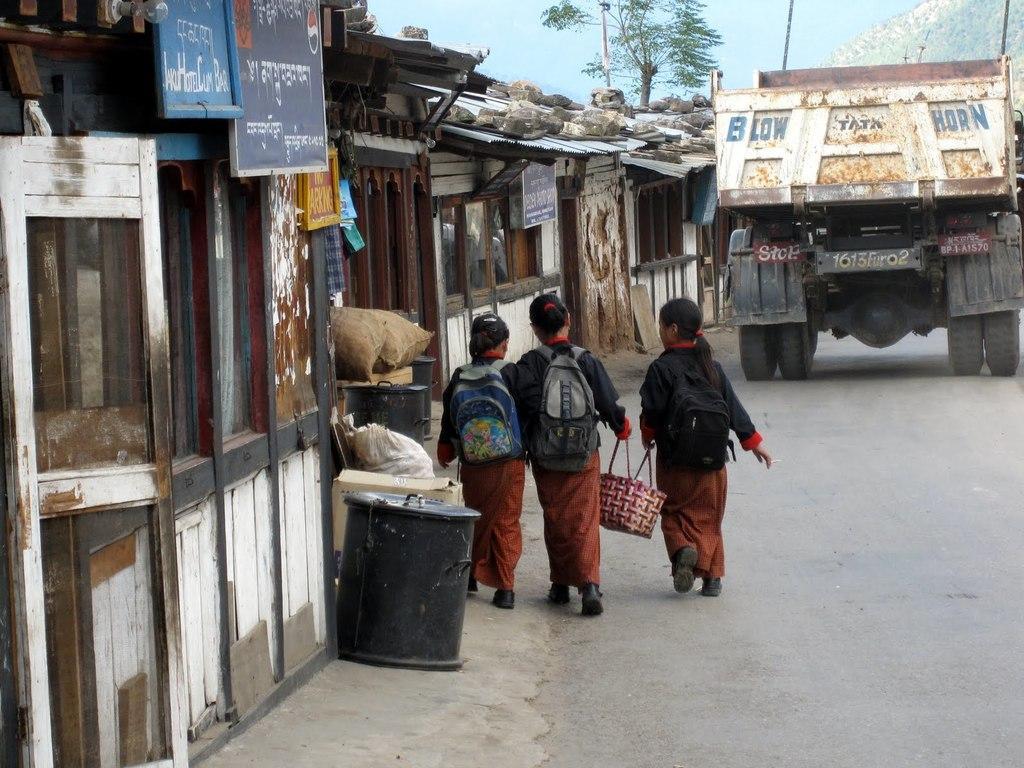How would you summarize this image in a sentence or two? A picture of an outside. This 3 girls are walking on a road, as we can see there is a leg movements. This 2 girls are holding a basket. This 3 girls carry bags. Beside this there is a store. This store has 2 boards. In-front of this store there is a container and a cart box. On a road a vehicle is travelling. Far there is a tree. 